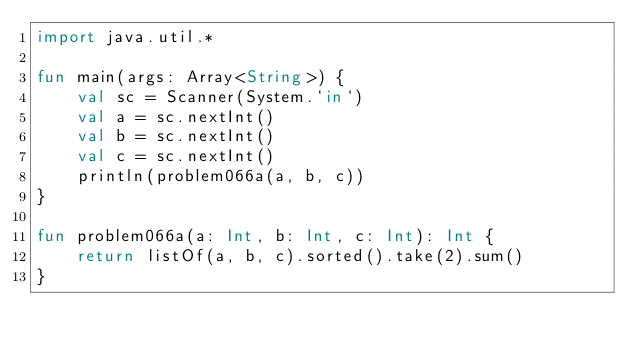<code> <loc_0><loc_0><loc_500><loc_500><_Kotlin_>import java.util.*

fun main(args: Array<String>) {
    val sc = Scanner(System.`in`)
    val a = sc.nextInt()
    val b = sc.nextInt()
    val c = sc.nextInt()
    println(problem066a(a, b, c))
}

fun problem066a(a: Int, b: Int, c: Int): Int {
    return listOf(a, b, c).sorted().take(2).sum()
}</code> 